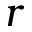Convert formula to latex. <formula><loc_0><loc_0><loc_500><loc_500>r</formula> 